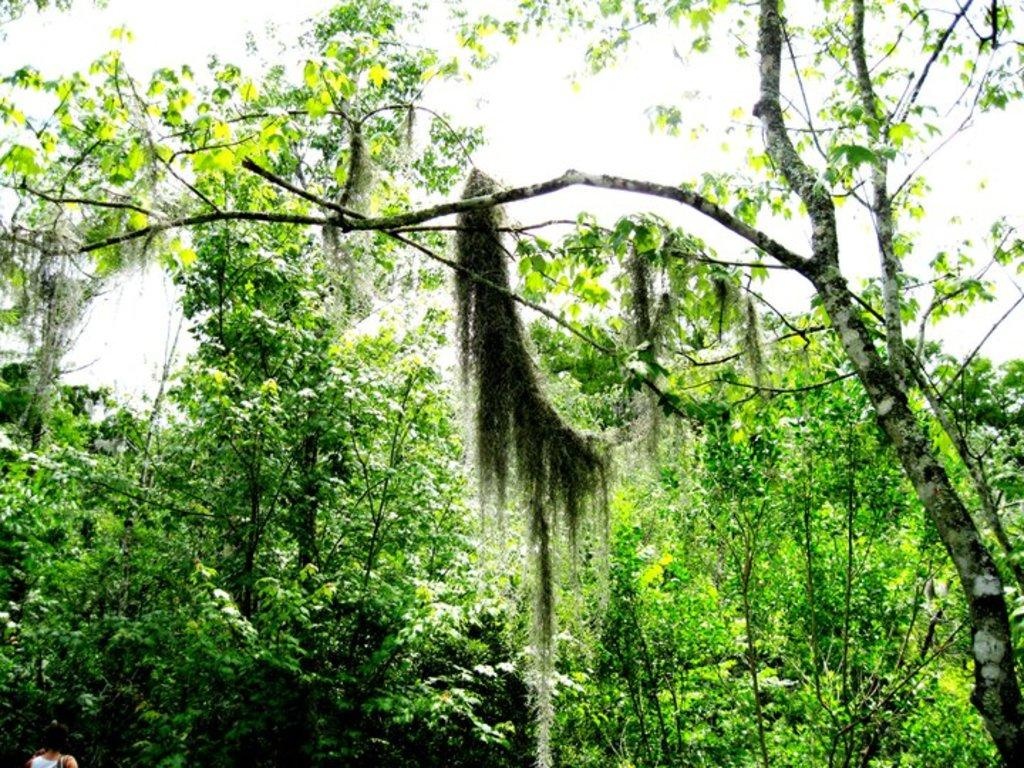What type of vegetation can be seen in the image? There are trees in the image. Who or what else is present in the image? There is a woman in the image. What type of floor can be seen in the image? There is no floor visible in the image; it only shows trees and a woman. 